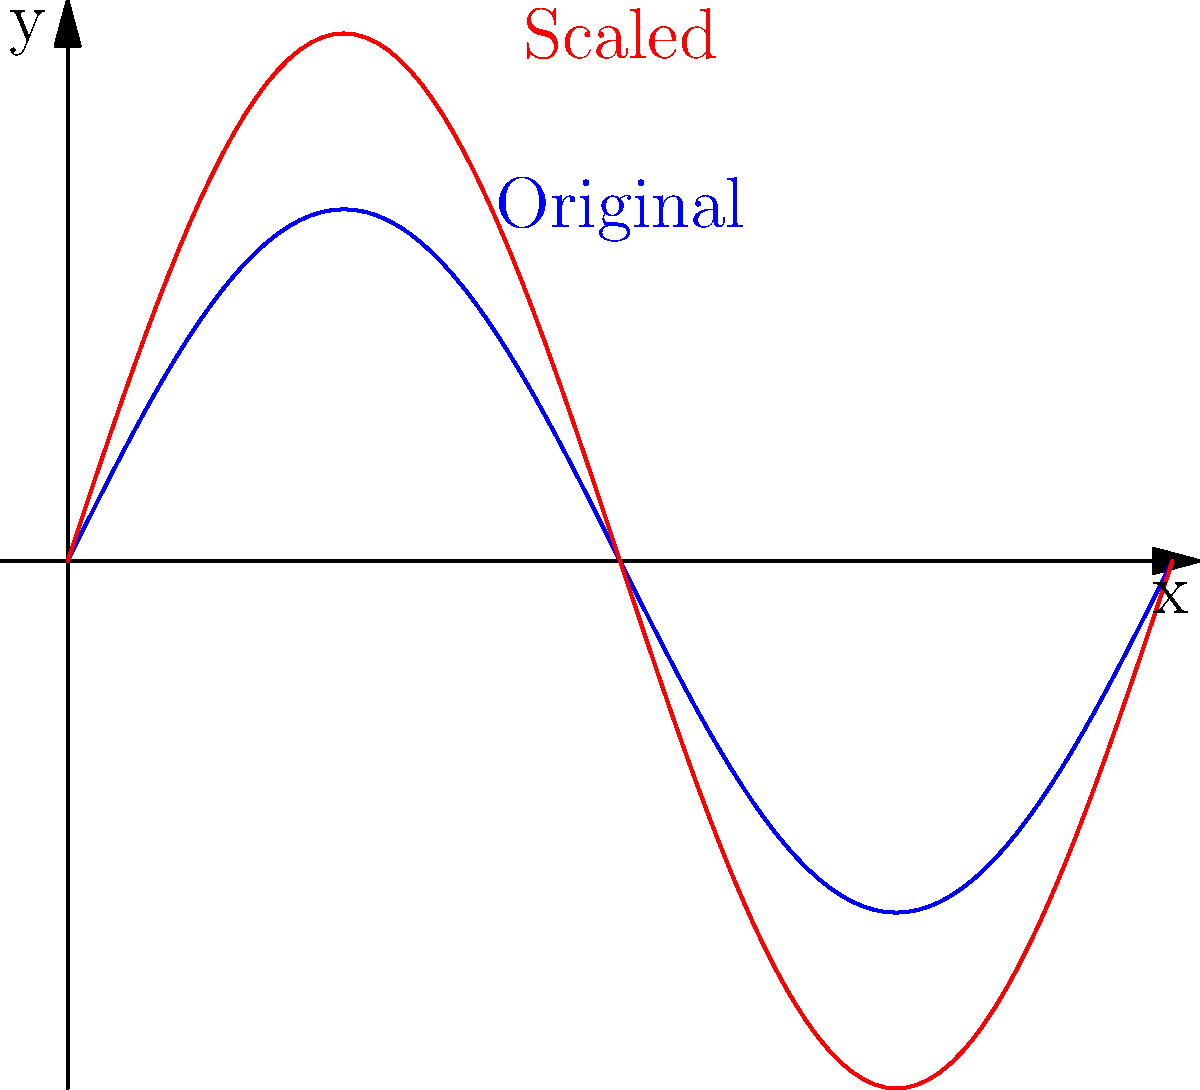A pharmaceutical molecule's 2D structure can be modeled by the function $f(x) = 2\sin(x)$ over the interval $[0, 2\pi]$. If the molecule is scaled uniformly by a factor of 1.5, resulting in the new function $g(x) = 3\sin(x)$, what is the ratio of the new surface area to the original surface area? Let's approach this step-by-step:

1) The surface area of a 2D curve is given by the arc length formula:
   $$L = \int_a^b \sqrt{1 + [f'(x)]^2} dx$$

2) For the original function $f(x) = 2\sin(x)$:
   $f'(x) = 2\cos(x)$
   $L_f = \int_0^{2\pi} \sqrt{1 + [2\cos(x)]^2} dx$

3) For the scaled function $g(x) = 3\sin(x)$:
   $g'(x) = 3\cos(x)$
   $L_g = \int_0^{2\pi} \sqrt{1 + [3\cos(x)]^2} dx$

4) The ratio of the new surface area to the original is:
   $$\frac{L_g}{L_f} = \frac{\int_0^{2\pi} \sqrt{1 + [3\cos(x)]^2} dx}{\int_0^{2\pi} \sqrt{1 + [2\cos(x)]^2} dx}$$

5) This is equivalent to:
   $$\frac{L_g}{L_f} = \frac{\int_0^{2\pi} \sqrt{1 + 9\cos^2(x)} dx}{\int_0^{2\pi} \sqrt{1 + 4\cos^2(x)} dx}$$

6) Observe that the numerator is exactly 1.5 times the denominator for all x.

7) Therefore, the ratio simplifies to 1.5.

This result aligns with the intuition that scaling a 2D object by a factor of 1.5 in all directions should increase its "surface area" (arc length in this case) by the same factor.
Answer: 1.5 